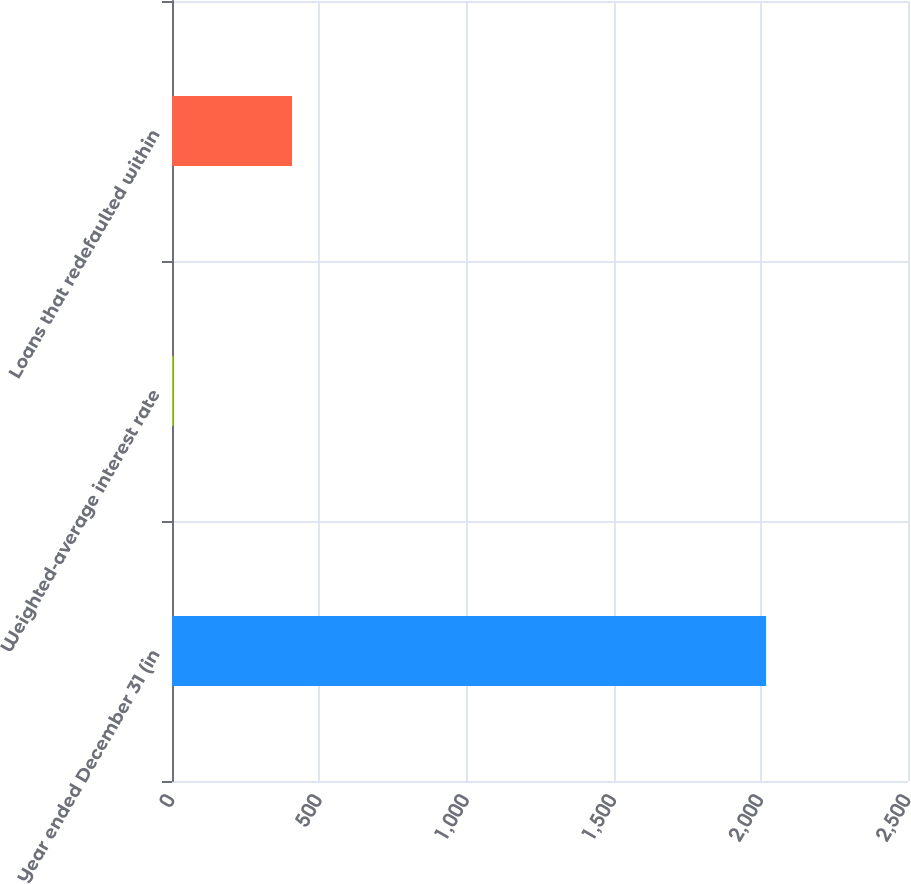Convert chart. <chart><loc_0><loc_0><loc_500><loc_500><bar_chart><fcel>Year ended December 31 (in<fcel>Weighted-average interest rate<fcel>Loans that redefaulted within<nl><fcel>2018<fcel>5.16<fcel>407.72<nl></chart> 